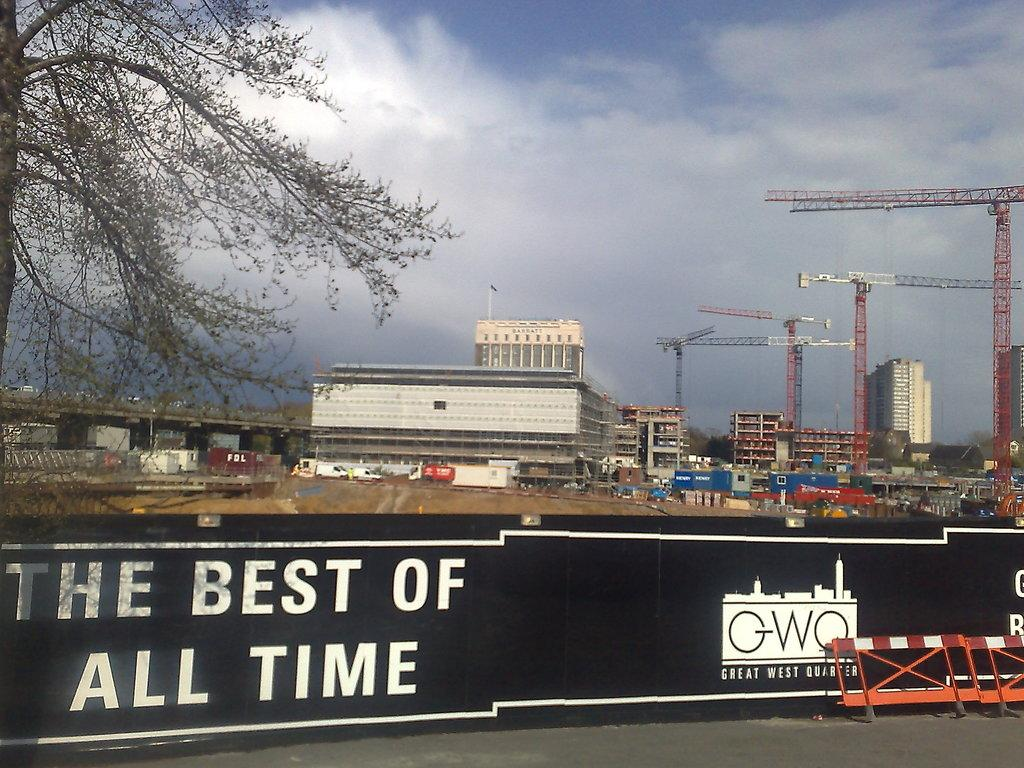Provide a one-sentence caption for the provided image. A fence bearing the words the best of all time separates people from a huge construction site. 